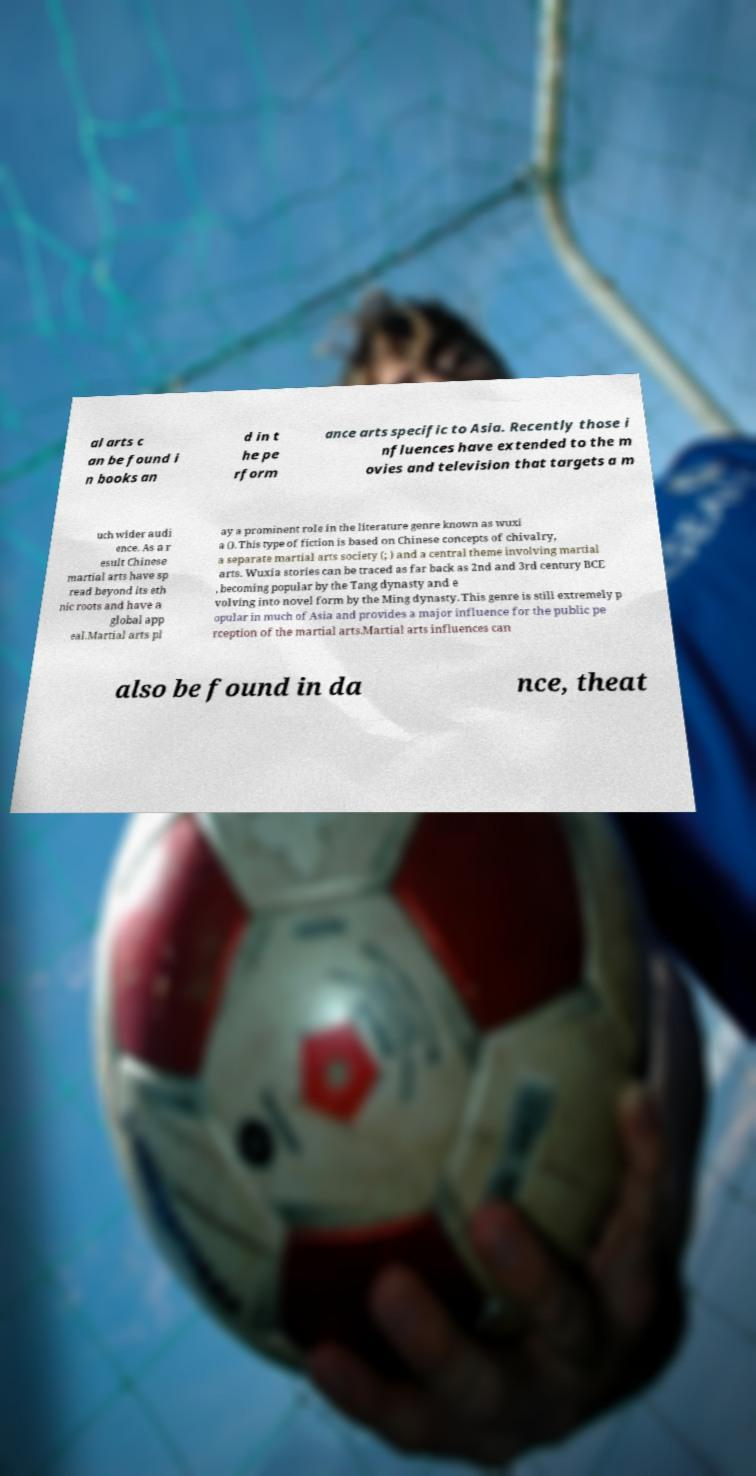Could you assist in decoding the text presented in this image and type it out clearly? al arts c an be found i n books an d in t he pe rform ance arts specific to Asia. Recently those i nfluences have extended to the m ovies and television that targets a m uch wider audi ence. As a r esult Chinese martial arts have sp read beyond its eth nic roots and have a global app eal.Martial arts pl ay a prominent role in the literature genre known as wuxi a (). This type of fiction is based on Chinese concepts of chivalry, a separate martial arts society (; ) and a central theme involving martial arts. Wuxia stories can be traced as far back as 2nd and 3rd century BCE , becoming popular by the Tang dynasty and e volving into novel form by the Ming dynasty. This genre is still extremely p opular in much of Asia and provides a major influence for the public pe rception of the martial arts.Martial arts influences can also be found in da nce, theat 